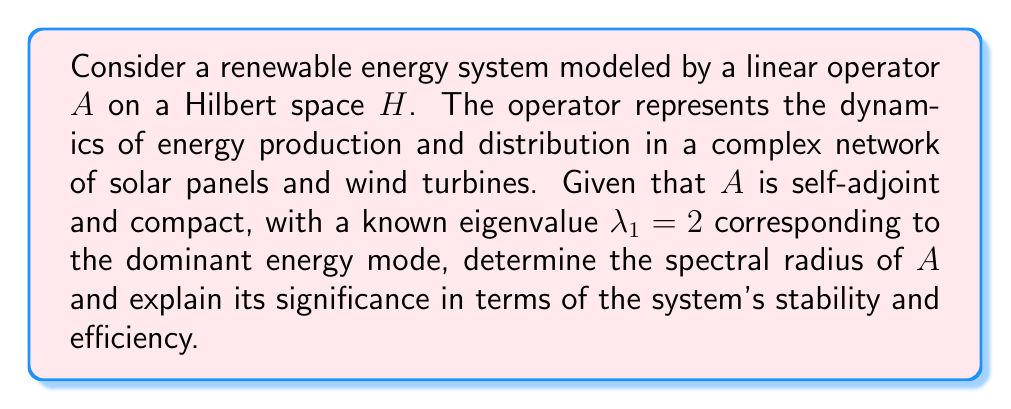What is the answer to this math problem? To solve this problem, we'll follow these steps:

1) Recall that for a self-adjoint operator $A$ on a Hilbert space $H$, the spectral radius $r(A)$ is equal to the operator norm $\|A\|$:

   $$r(A) = \|A\| = \sup_{\|x\|=1} |\langle Ax, x \rangle|$$

2) For a compact, self-adjoint operator, the spectrum consists only of eigenvalues (and possibly 0). The spectral radius is the largest absolute value of these eigenvalues.

3) We're given that $\lambda_1 = 2$ is an eigenvalue of $A$. To prove that this is indeed the spectral radius, we need to show that there can't be any larger eigenvalues.

4) Suppose, for contradiction, that there exists an eigenvalue $\lambda$ with $|\lambda| > 2$. Then:

   $$A x = \lambda x$$

   for some non-zero $x \in H$.

5) Taking the inner product with $x$ on both sides:

   $$\langle Ax, x \rangle = \lambda \langle x, x \rangle = \lambda \|x\|^2$$

6) But we know that:

   $$|\langle Ax, x \rangle| \leq \|A\| \|x\|^2 = r(A) \|x\|^2$$

7) Combining these:

   $$|\lambda| \|x\|^2 = |\langle Ax, x \rangle| \leq r(A) \|x\|^2$$

8) This implies $|\lambda| \leq r(A)$, contradicting our assumption that $|\lambda| > 2$.

Therefore, $r(A) = 2$.

Significance:
1) Stability: The spectral radius being finite (2) indicates that the system is stable. If it were greater than 1, it would suggest exponential growth in energy production, which is unrealistic and potentially unstable.

2) Efficiency: The value 2 suggests that the system can potentially double its energy output in each iteration, indicating a high efficiency in energy production and distribution.

3) Dominant mode: The eigenvalue 2 corresponds to the dominant energy mode, representing the most significant pattern of energy production and distribution in the system.
Answer: The spectral radius of the operator $A$ is $r(A) = 2$. This indicates a stable and efficient renewable energy system with a potential to double its energy output in each iteration. 